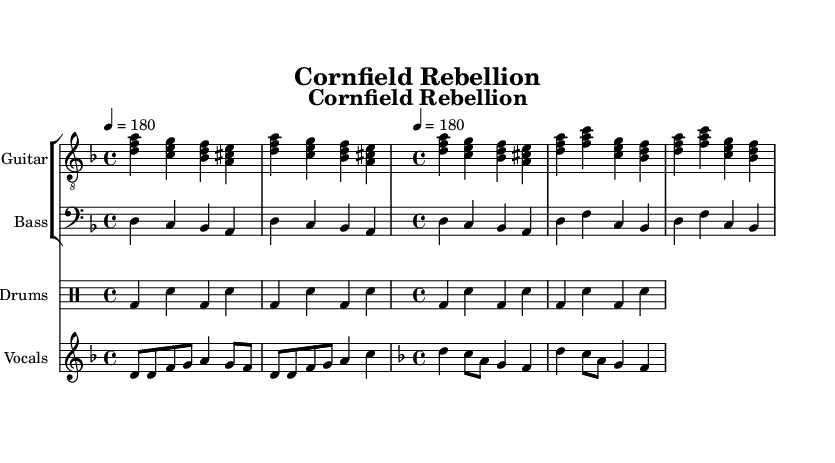What is the key signature of this music? The key signature is represented at the beginning of the score. It shows one flat, indicating the piece is in D minor.
Answer: D minor What is the time signature of this music? The time signature is found in the initial section of the music notation, indicated as 4/4, which means there are four beats per measure.
Answer: 4/4 What is the tempo marking for the piece? The tempo marking is indicated by the tempo setting at the beginning of the score, which states 4 equals 180, meaning 180 beats per minute.
Answer: 180 How many measures are in the verse section? The verse section consists of 2 iterations of the chords over 4 measures each. Counting the measures gives a total of 8 measures in the verse.
Answer: 8 measures What type of musical instrument is primarily featured in the piece? The score shows several staves, including one labeled as "Electric Guitar," indicating that this is a prominent instrument throughout the piece.
Answer: Electric Guitar How is the rhythm characterized in this piece? The rhythmic structure features a basic punk beat, characterized by a steady kick drum and snare alternation throughout the piece, which gives it a driving energy typical of punk music.
Answer: Basic punk beat How does the chorus section differ from the verse section in terms of lyrics? The chorus lyrics are more evocative and call to action compared to the verse, focusing on themes of rebellion and guardianship, evident in the lyrics that talk about a "scarecrow army."
Answer: More evocative and action-oriented 